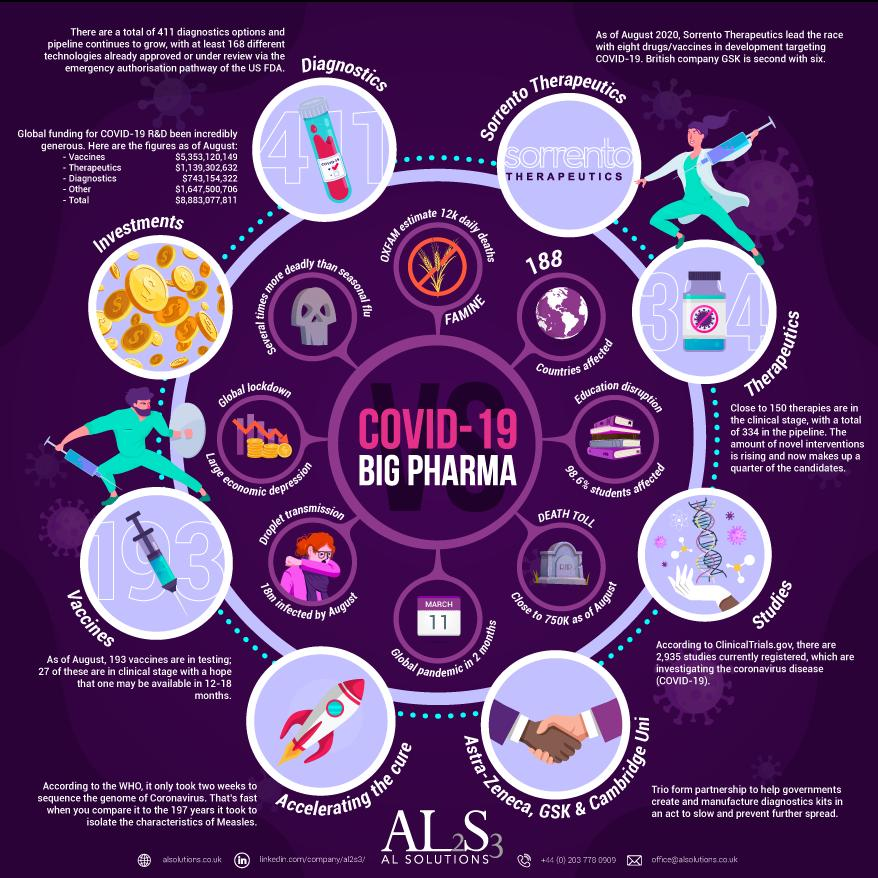Give some essential details in this illustration. As of August 2020, the global funding for COVID-19 R&D in diagnostics was approximately $743,154,322. As of August 2020, the total global funding for COVID-19 R&D was $8,883,077,811. As of August 2020, it is estimated that the COVID-19 pandemic has had a significant impact on the education of students, with 98.6% of their education being affected. According to OXFAM's estimate, as many as 12,000 people per day could die from Covid-related hunger. As of August 2020, the death toll due to Covid-19 is close to 750,000. 